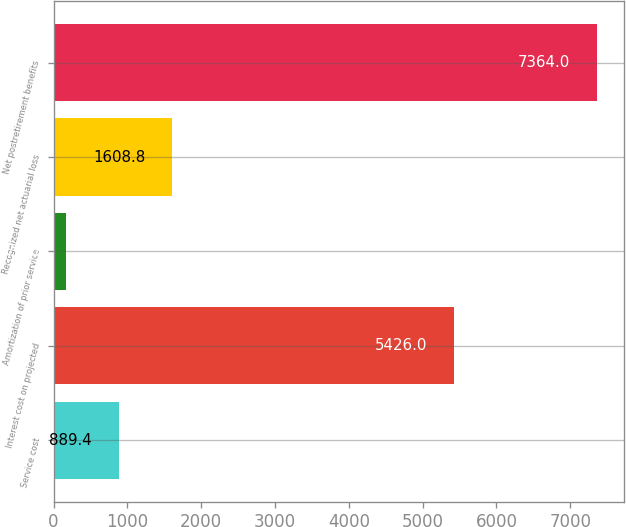Convert chart. <chart><loc_0><loc_0><loc_500><loc_500><bar_chart><fcel>Service cost<fcel>Interest cost on projected<fcel>Amortization of prior service<fcel>Recognized net actuarial loss<fcel>Net postretirement benefits<nl><fcel>889.4<fcel>5426<fcel>170<fcel>1608.8<fcel>7364<nl></chart> 